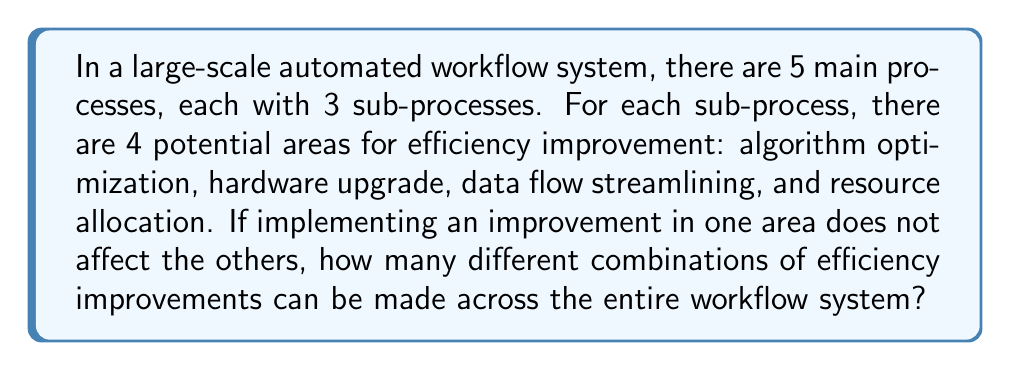Solve this math problem. Let's approach this step-by-step:

1) First, we need to determine the total number of sub-processes:
   $5 \text{ main processes} \times 3 \text{ sub-processes per main process} = 15 \text{ sub-processes}$

2) For each sub-process, we have 4 potential areas for improvement. Each area can either be improved or not, giving us 2 choices per area.

3) This scenario can be modeled as a combination problem. For each sub-process, we're essentially making 4 independent yes/no decisions.

4) The number of possibilities for each sub-process is thus:
   $2^4 = 16$ (because each of the 4 areas has 2 choices)

5) Since we have 15 sub-processes, and the improvements in each sub-process are independent of the others, we can use the multiplication principle.

6) The total number of possible combinations is:
   $16^{15}$

7) This can be written as:
   $$(2^4)^{15} = 2^{60}$$

Therefore, there are $2^{60}$ different possible combinations of efficiency improvements across the entire workflow system.
Answer: $2^{60}$ 